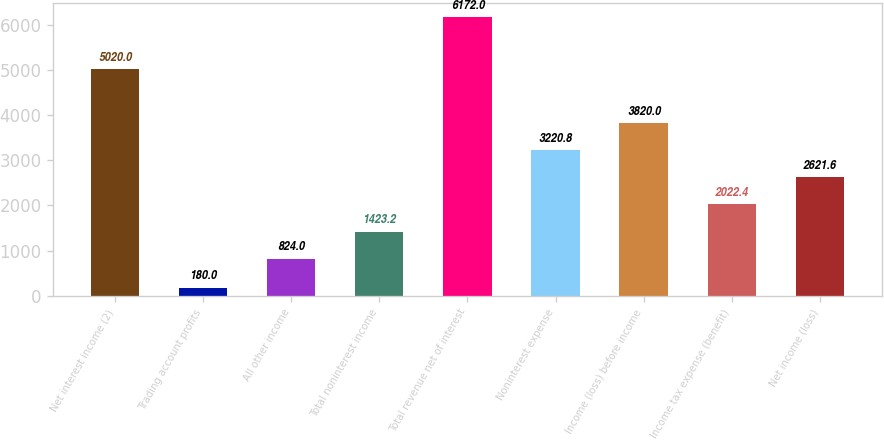Convert chart to OTSL. <chart><loc_0><loc_0><loc_500><loc_500><bar_chart><fcel>Net interest income (2)<fcel>Trading account profits<fcel>All other income<fcel>Total noninterest income<fcel>Total revenue net of interest<fcel>Noninterest expense<fcel>Income (loss) before income<fcel>Income tax expense (benefit)<fcel>Net income (loss)<nl><fcel>5020<fcel>180<fcel>824<fcel>1423.2<fcel>6172<fcel>3220.8<fcel>3820<fcel>2022.4<fcel>2621.6<nl></chart> 